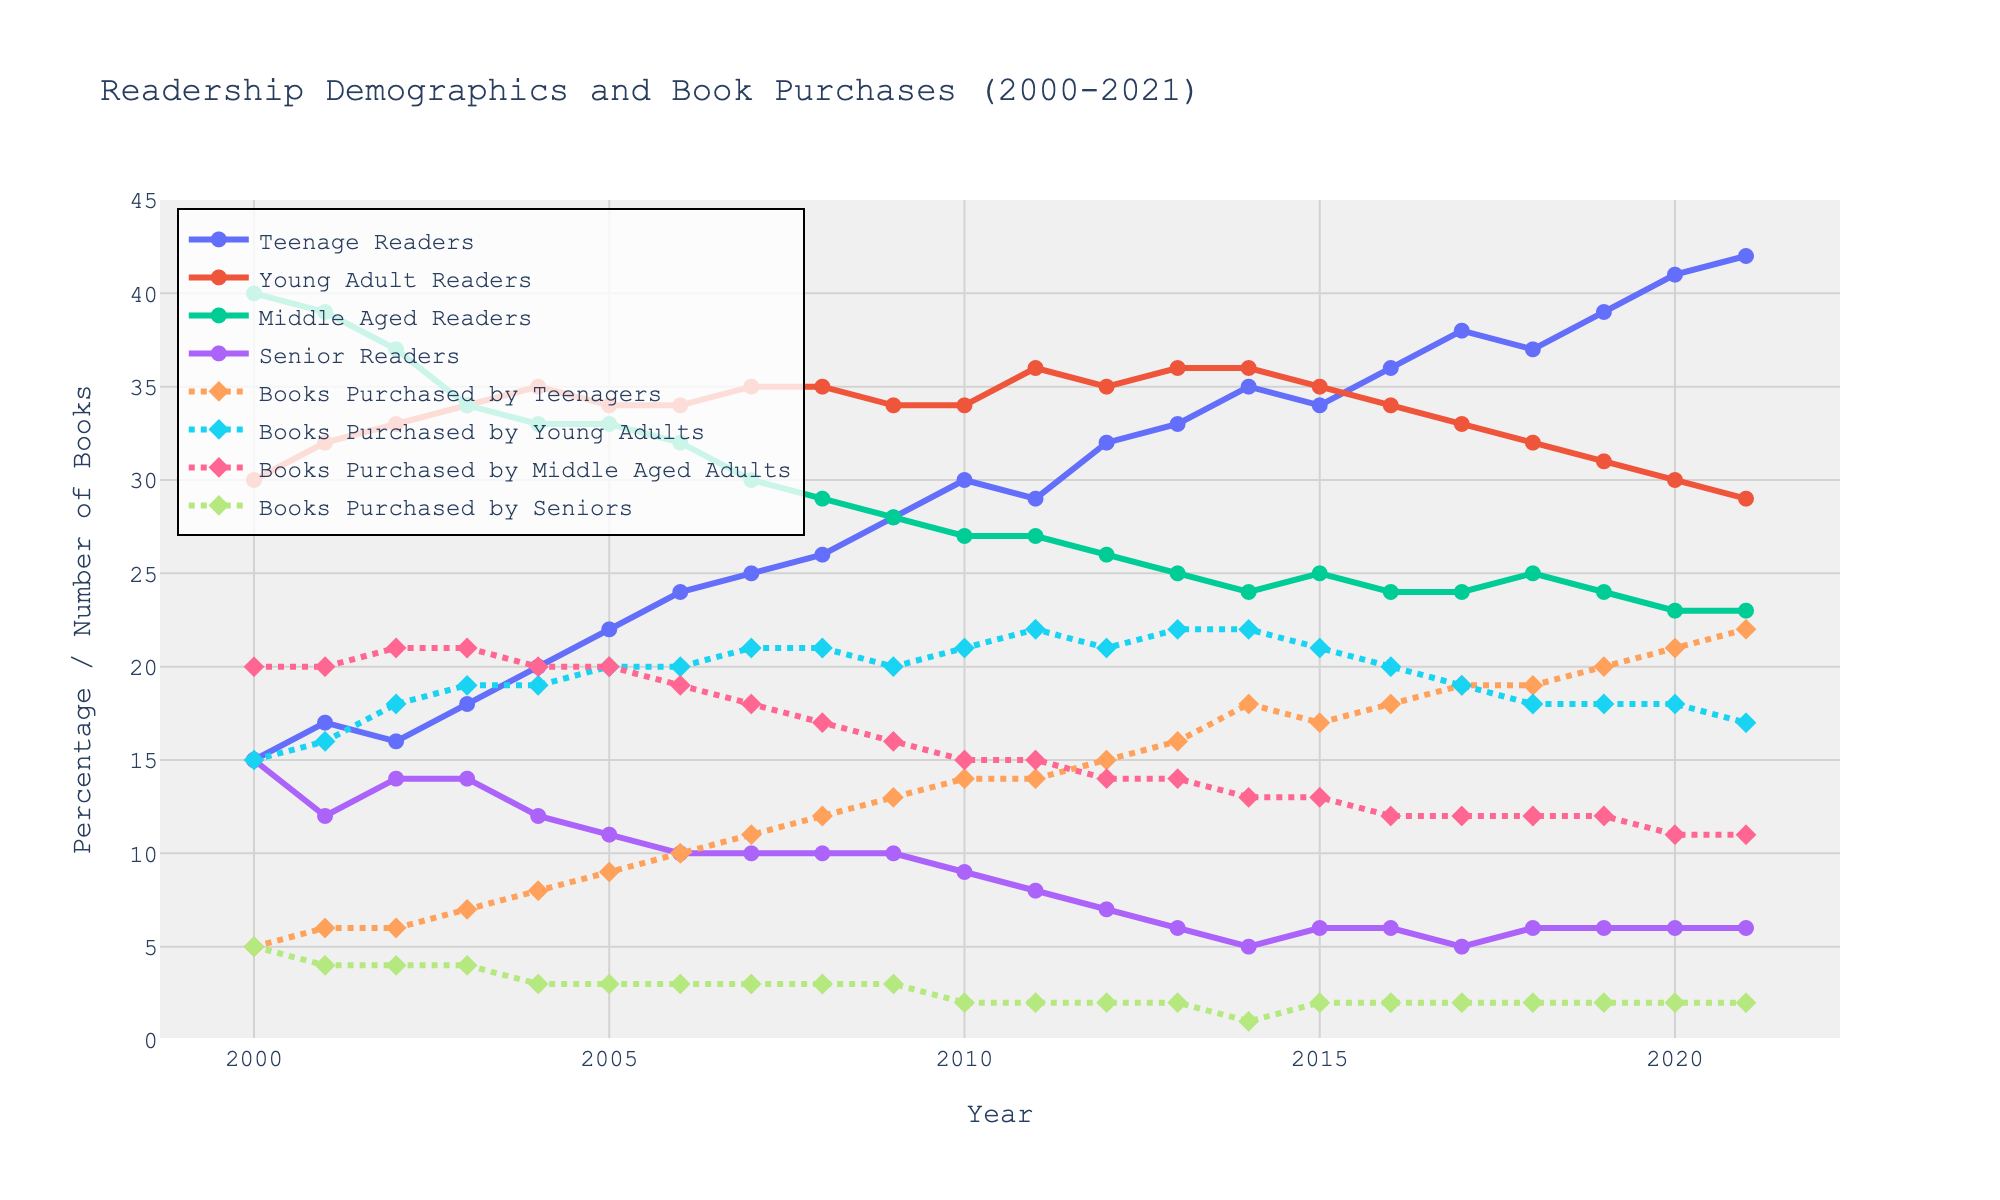What is the general trend for the percentage of teenage readers from 2000 to 2021? Over the years, the percentage of teenage readers has generally increased. The percentage starts at 15% in 2000 and ends at 42% in 2021, showing a clear upward trend.
Answer: Increasing How did the number of books purchased by young adults change from 2000 to 2021? The number of books purchased by young adults shows a slight upward trend initially, peaking around 2010 and then slightly decreasing towards 2021. It starts at 15 books in 2000, rises to around 22 in 2011 and drops to 17 in 2021.
Answer: Increased initially, then decreased What was the highest number of books purchased by teenagers in any given year? Examining the plot for the “Books Purchased by Teenagers” line, the highest value is seen to be 22 books in the year 2021.
Answer: 22 Between middle-aged readers and senior readers, which group shows a steeper decline in percentage from 2000 to 2021? The line for senior readers starts at 15% in 2000 and drops to 6% in 2021, while middle-aged readers start at 40% and drop to 23%. Given the starting and ending points, senior readers show a more dramatic relative decrease.
Answer: Senior readers What is the maximum percentage of young adult readers over the years, and which year does it occur? The plot shows that the percentage of young adult readers peaks around 36% in 2003, 2011, 2013, and 2014.
Answer: 36%, multiple years (2003, 2011, 2013, 2014) How many more books did middle-aged adults purchase in 2005 than in 2021? In 2005, middle-aged adults purchased 20 books and in 2021 they purchased 11. The difference is calculated as 20 - 11 = 9.
Answer: 9 Which year shows the largest decrease in the percentage of senior readers compared to the previous year? The largest single-year drop for senior readers appears between 2000 (15%) and 2001 (12%), a decrease of 3%.
Answer: 2001 What is the total number of books purchased by all demographic groups in 2014? Summing the number of books purchased by each group in 2014: 18 (Teenagers) + 22 (Young Adults) + 13 (Middle-aged Adults) + 1 (Seniors) = 54 books.
Answer: 54 Compare the trends of teenage readers and young adult readers from 2000 to 2021. Teenage readers show a consistent increase, rising from 15% to 42%. Young adult readers, however, show fluctuation around 30-36% without a strong upward or downward trend, ending at 29%.
Answer: Teenage readers increased consistently, young adult readers fluctuated 